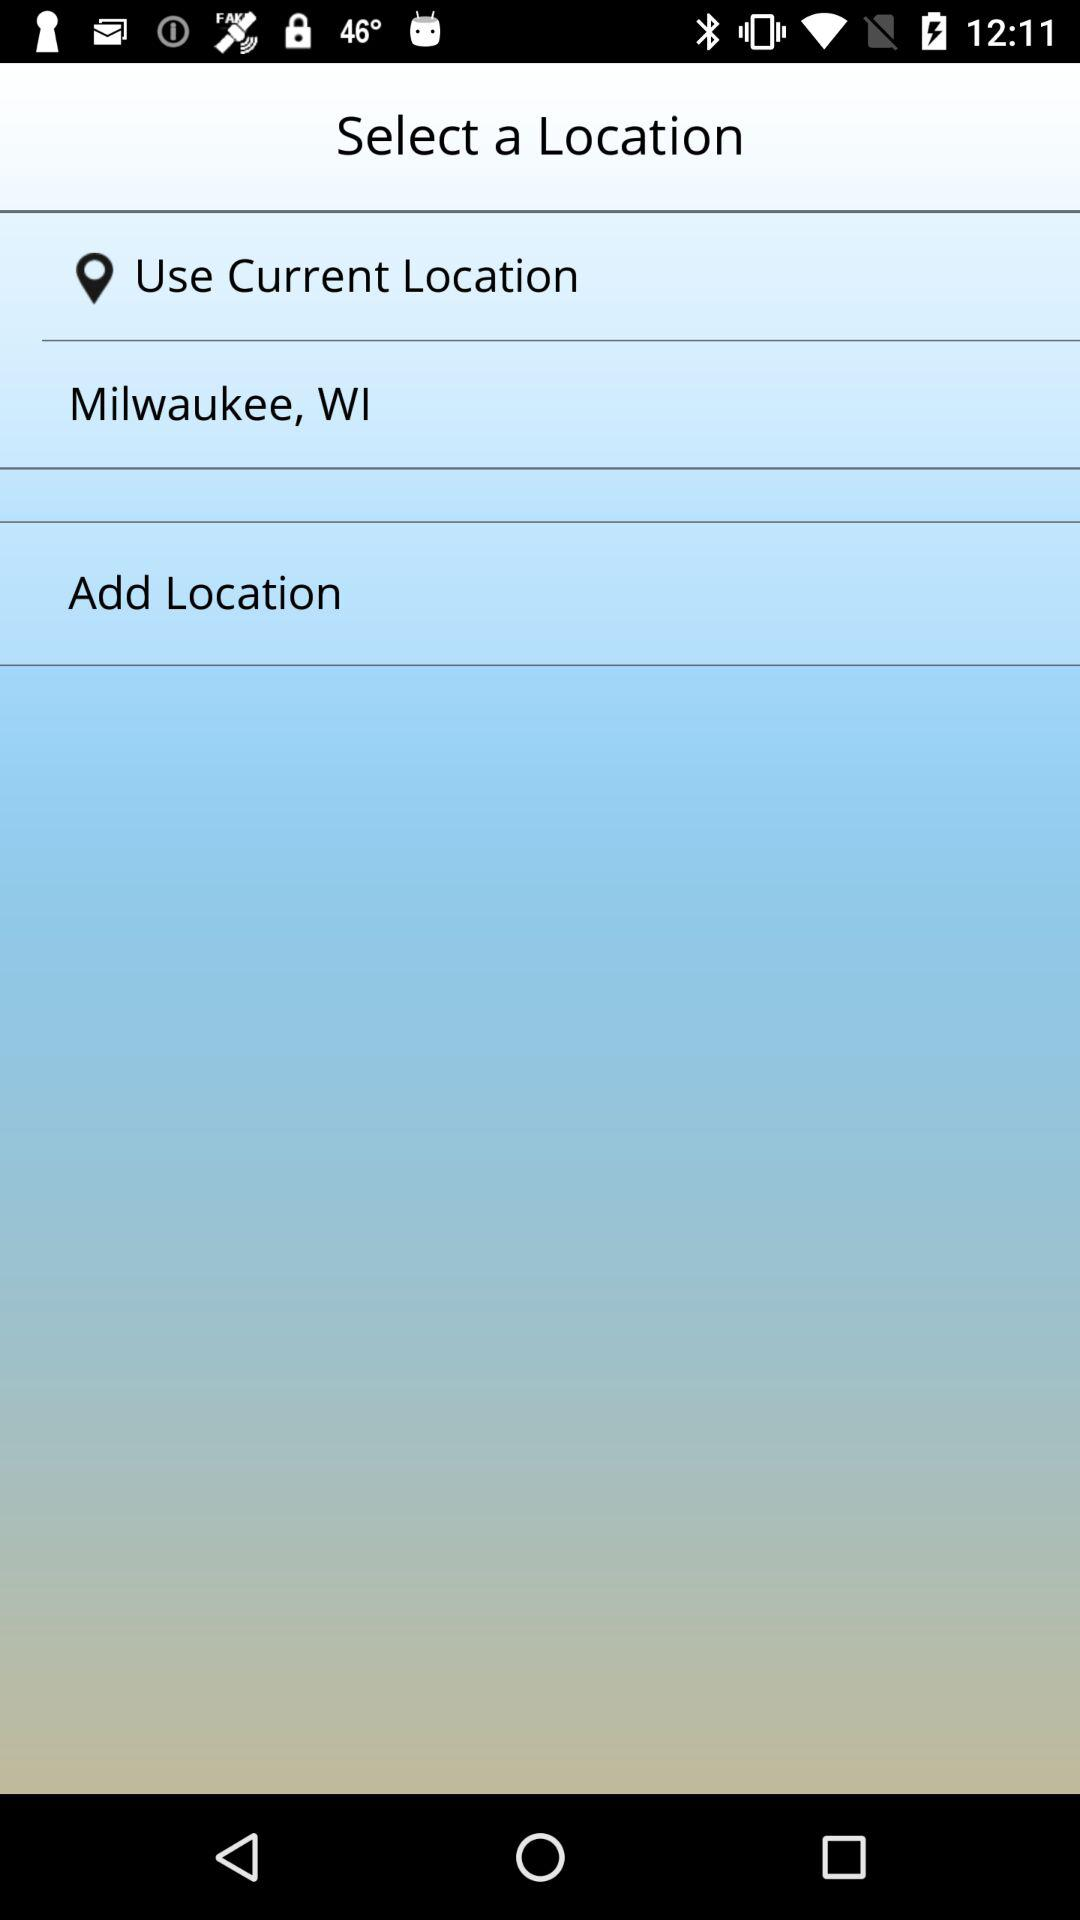What place is in the current location? The current location is Milwaukee, WI. 